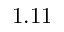Convert formula to latex. <formula><loc_0><loc_0><loc_500><loc_500>1 . 1 1</formula> 